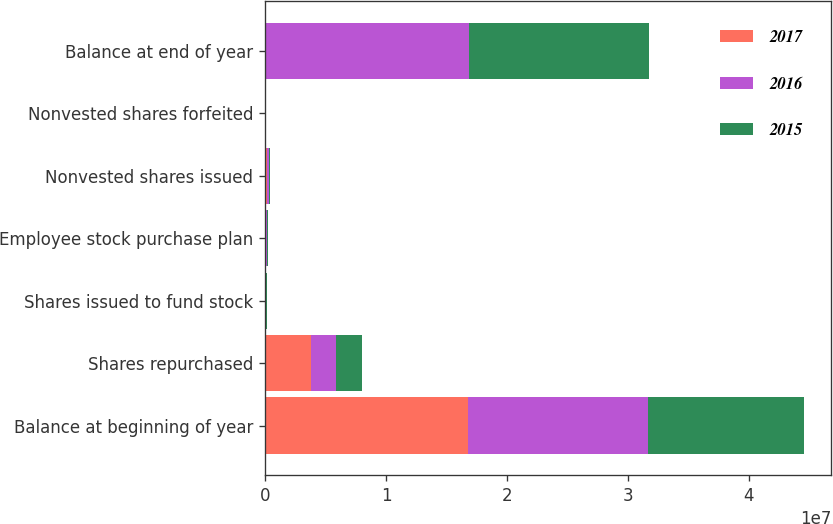Convert chart. <chart><loc_0><loc_0><loc_500><loc_500><stacked_bar_chart><ecel><fcel>Balance at beginning of year<fcel>Shares repurchased<fcel>Shares issued to fund stock<fcel>Employee stock purchase plan<fcel>Nonvested shares issued<fcel>Nonvested shares forfeited<fcel>Balance at end of year<nl><fcel>2017<fcel>1.67456e+07<fcel>3.75968e+06<fcel>9110<fcel>76401<fcel>124519<fcel>20166<fcel>106777<nl><fcel>2016<fcel>1.4891e+07<fcel>2.12761e+06<fcel>15264<fcel>82372<fcel>179309<fcel>3858<fcel>1.67456e+07<nl><fcel>2015<fcel>1.29599e+07<fcel>2.13398e+06<fcel>89035<fcel>52736<fcel>62936<fcel>1909<fcel>1.4891e+07<nl></chart> 